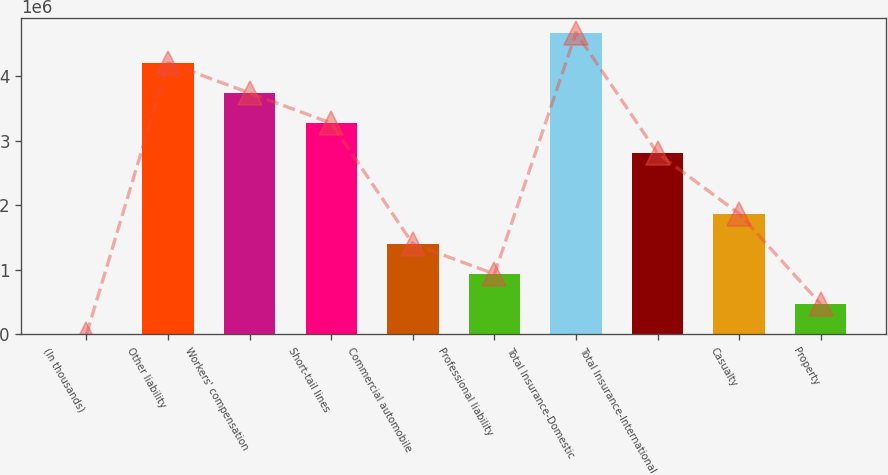<chart> <loc_0><loc_0><loc_500><loc_500><bar_chart><fcel>(In thousands)<fcel>Other liability<fcel>Workers' compensation<fcel>Short-tail lines<fcel>Commercial automobile<fcel>Professional liability<fcel>Total Insurance-Domestic<fcel>Total Insurance-International<fcel>Casualty<fcel>Property<nl><fcel>2012<fcel>4.20637e+06<fcel>3.73922e+06<fcel>3.27206e+06<fcel>1.40346e+06<fcel>936313<fcel>4.67352e+06<fcel>2.80491e+06<fcel>1.87061e+06<fcel>469162<nl></chart> 